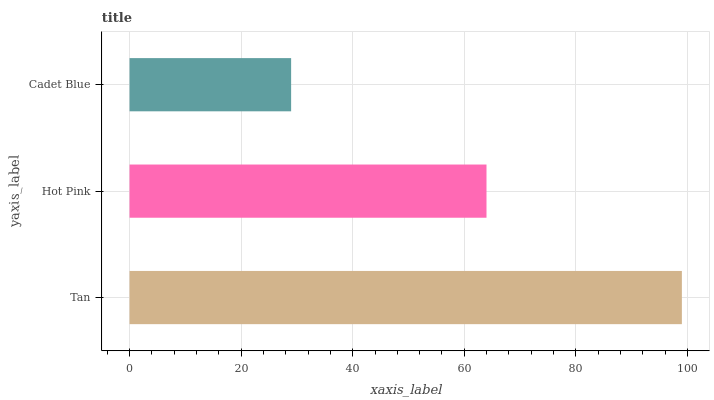Is Cadet Blue the minimum?
Answer yes or no. Yes. Is Tan the maximum?
Answer yes or no. Yes. Is Hot Pink the minimum?
Answer yes or no. No. Is Hot Pink the maximum?
Answer yes or no. No. Is Tan greater than Hot Pink?
Answer yes or no. Yes. Is Hot Pink less than Tan?
Answer yes or no. Yes. Is Hot Pink greater than Tan?
Answer yes or no. No. Is Tan less than Hot Pink?
Answer yes or no. No. Is Hot Pink the high median?
Answer yes or no. Yes. Is Hot Pink the low median?
Answer yes or no. Yes. Is Tan the high median?
Answer yes or no. No. Is Cadet Blue the low median?
Answer yes or no. No. 